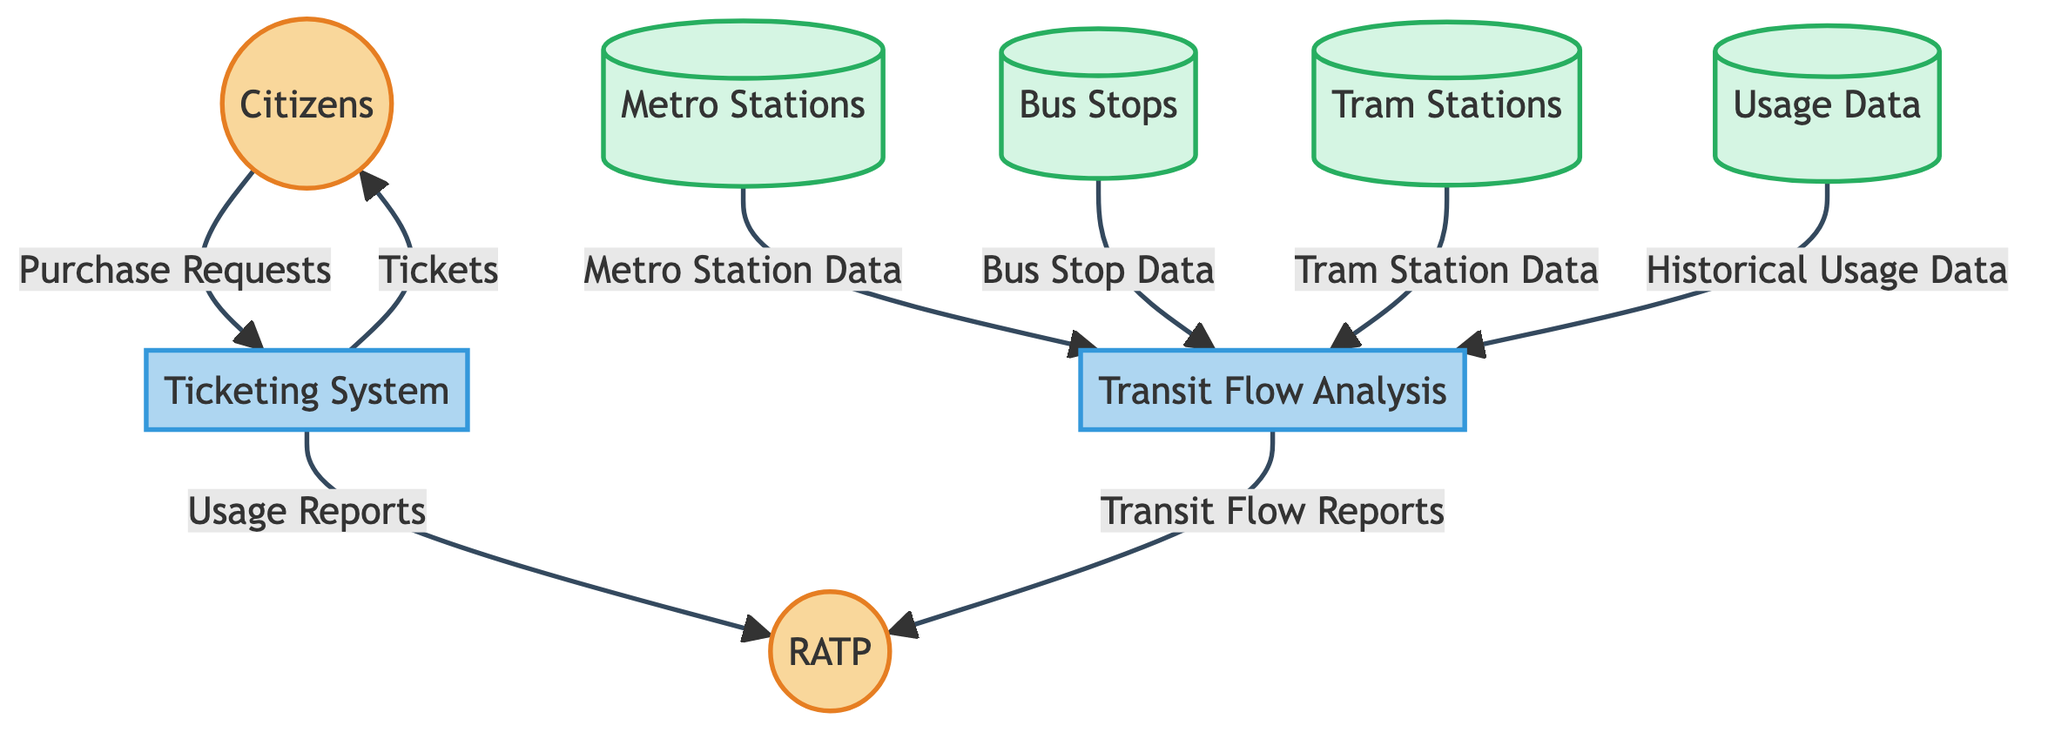What is the total number of entities in this diagram? The diagram contains a total of 7 entities, namely Citizens, RATP, Ticketing System, Metro Stations, Bus Stops, Tram Stations, and Usage Data. Counting each of these gives the total.
Answer: 7 Which entity does the Ticketing System send Tickets to? The Ticketing System directs the output of Tickets to the Citizens entity, which is shown as a data flow from Ticketing System to Citizens.
Answer: Citizens What data flows from Citizens to the Ticketing System? The data that flows from Citizens to the Ticketing System is defined as Purchase Requests, as indicated by the arrow and label in the diagram.
Answer: Purchase Requests How many data stores are represented in the diagram? There are 4 data stores depicted in the diagram: Metro Stations, Bus Stops, Tram Stations, and Usage Data. This can be counted by identifying nodes labeled as Data Store.
Answer: 4 Which process uses Historical Usage Data? The process that uses Historical Usage Data is the Transit Flow Analysis, as there is a direct data flow from Usage Data to Transit Flow Analysis labeled with that data.
Answer: Transit Flow Analysis What type of data does the Ticketing System send to RATP? The Ticketing System sends Usage Reports to RATP, which is indicated by the data flow from Ticketing System to RATP.
Answer: Usage Reports Which entities provide data to Transit Flow Analysis? The entities providing data to Transit Flow Analysis are Metro Stations, Bus Stops, Tram Stations, and Usage Data. Each of these entities has a directed data flow leading to Transit Flow Analysis.
Answer: Metro Stations, Bus Stops, Tram Stations, Usage Data What is the relationship between RATP and Transit Flow Analysis? RATP receives Transit Flow Reports from Transit Flow Analysis, demonstrating a data flow relationship where Transit Flow Analysis outputs reports to RATP.
Answer: Transit Flow Reports What type of entity is the Ticketing System? The Ticketing System is categorized as a Process within the diagram, which is specified by the labels and colors used to represent different entity types.
Answer: Process 